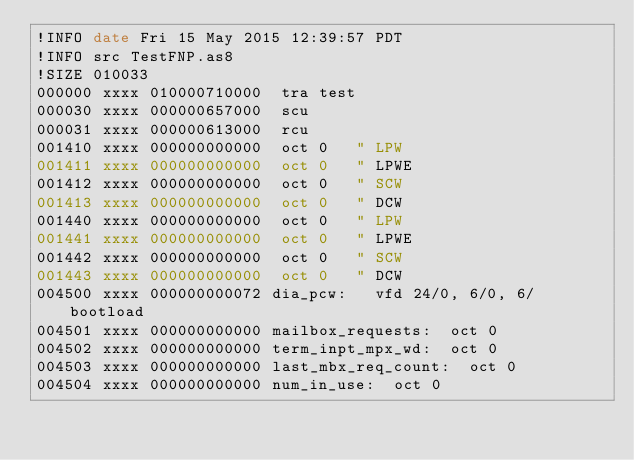<code> <loc_0><loc_0><loc_500><loc_500><_Octave_>!INFO date Fri 15 May 2015 12:39:57 PDT
!INFO src TestFNP.as8
!SIZE 010033
000000 xxxx 010000710000 	tra	test
000030 xxxx 000000657000 	scu
000031 xxxx 000000613000 	rcu
001410 xxxx 000000000000 	oct	0		" LPW
001411 xxxx 000000000000 	oct	0		" LPWE
001412 xxxx 000000000000 	oct	0		" SCW
001413 xxxx 000000000000 	oct	0		" DCW
001440 xxxx 000000000000 	oct	0		" LPW
001441 xxxx 000000000000 	oct	0		" LPWE
001442 xxxx 000000000000 	oct	0		" SCW
001443 xxxx 000000000000 	oct	0		" DCW
004500 xxxx 000000000072 dia_pcw:		vfd	24/0, 6/0, 6/bootload
004501 xxxx 000000000000 mailbox_requests:	oct	0
004502 xxxx 000000000000 term_inpt_mpx_wd:	oct	0
004503 xxxx 000000000000 last_mbx_req_count:	oct	0
004504 xxxx 000000000000 num_in_use:	oct	0</code> 